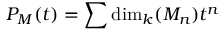<formula> <loc_0><loc_0><loc_500><loc_500>P _ { M } ( t ) = \sum \dim _ { k } ( M _ { n } ) t ^ { n }</formula> 